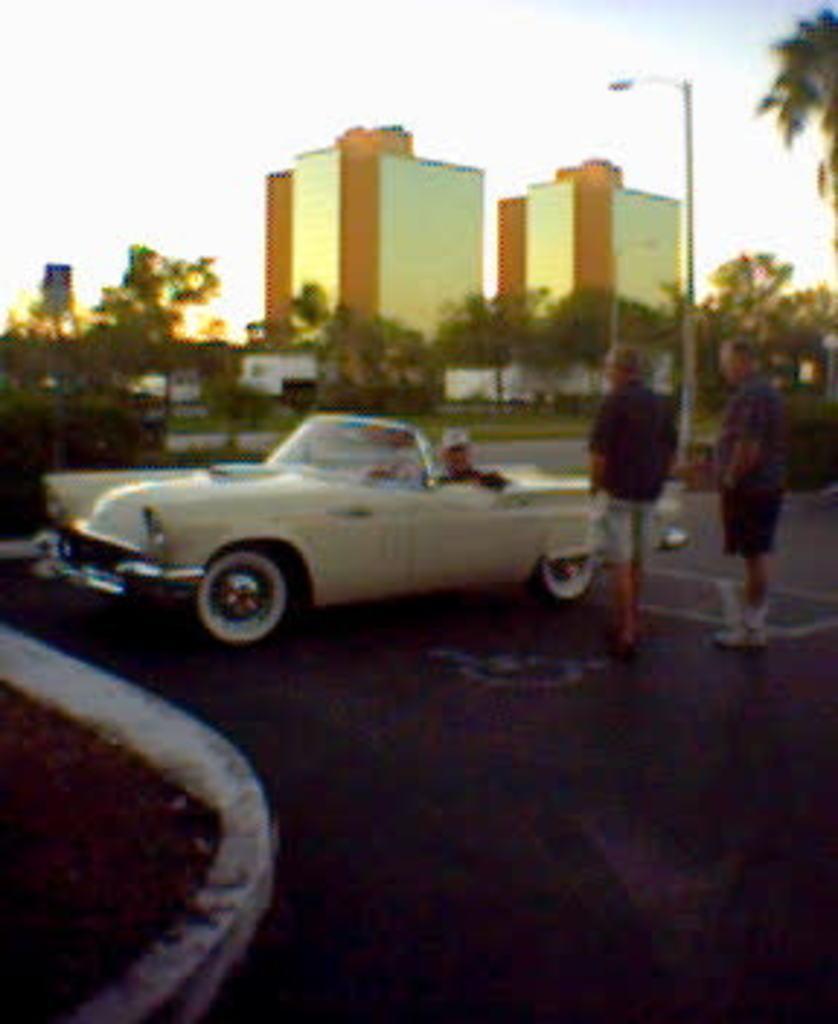Describe this image in one or two sentences. This picture shows a car parked and we see two people standing and we can see few buildings and few trees around 